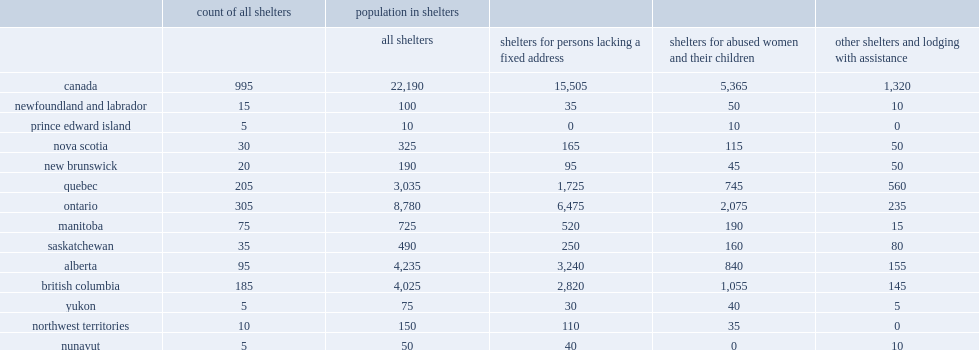How many shelters did the 2016 census count? 995.0. How many usual residents among shelters the 2016 census counted ? 22190.0. What was the proportion of usual residents in shelters enumerated at shelters for individuals with no fixed address? 0.698738. How many usual residents in shelters have been enumerated at shelters for individuals with no fixed address? 15505.0. How many shelter residents were in alberta? 4235.0. What percentage of shelters for abused women and their children did ontario have? 0.386766. What percentage of other shelter residents were in quebec? 0.424242. How many shelters that reported having usual residents in ontario? 305.0. How many shelters that reported having usual residents in quebec? 205.0. 